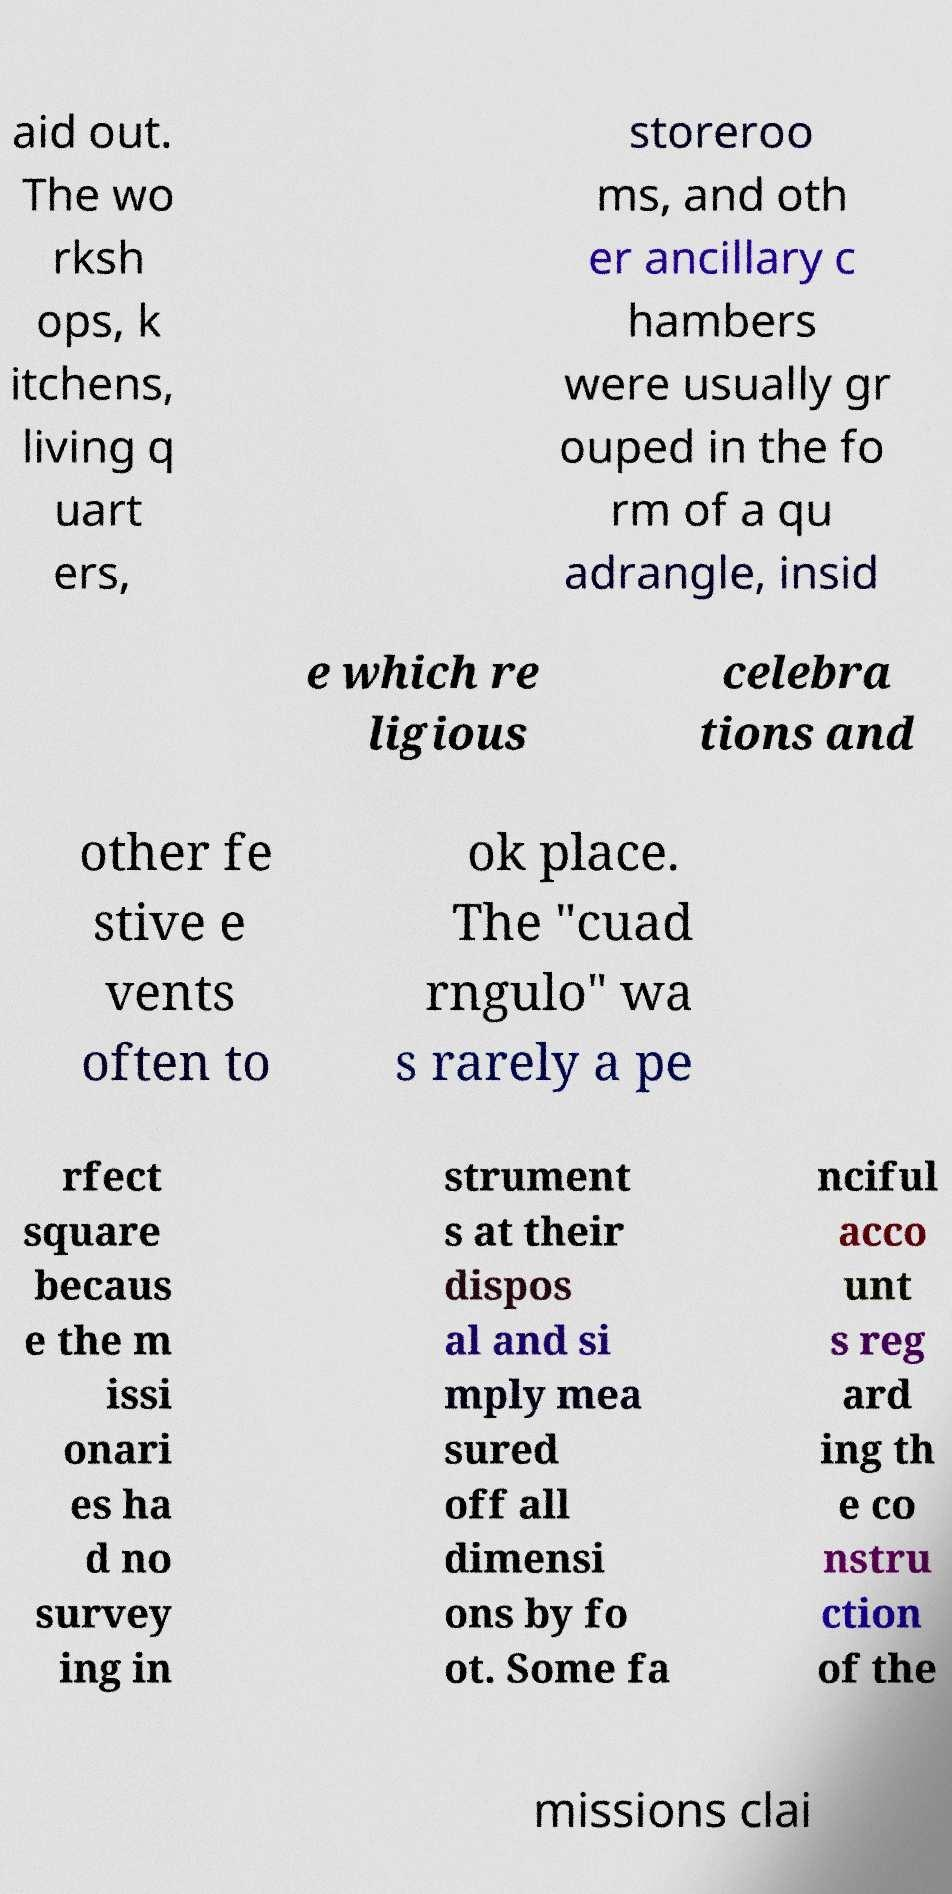There's text embedded in this image that I need extracted. Can you transcribe it verbatim? aid out. The wo rksh ops, k itchens, living q uart ers, storeroo ms, and oth er ancillary c hambers were usually gr ouped in the fo rm of a qu adrangle, insid e which re ligious celebra tions and other fe stive e vents often to ok place. The "cuad rngulo" wa s rarely a pe rfect square becaus e the m issi onari es ha d no survey ing in strument s at their dispos al and si mply mea sured off all dimensi ons by fo ot. Some fa nciful acco unt s reg ard ing th e co nstru ction of the missions clai 